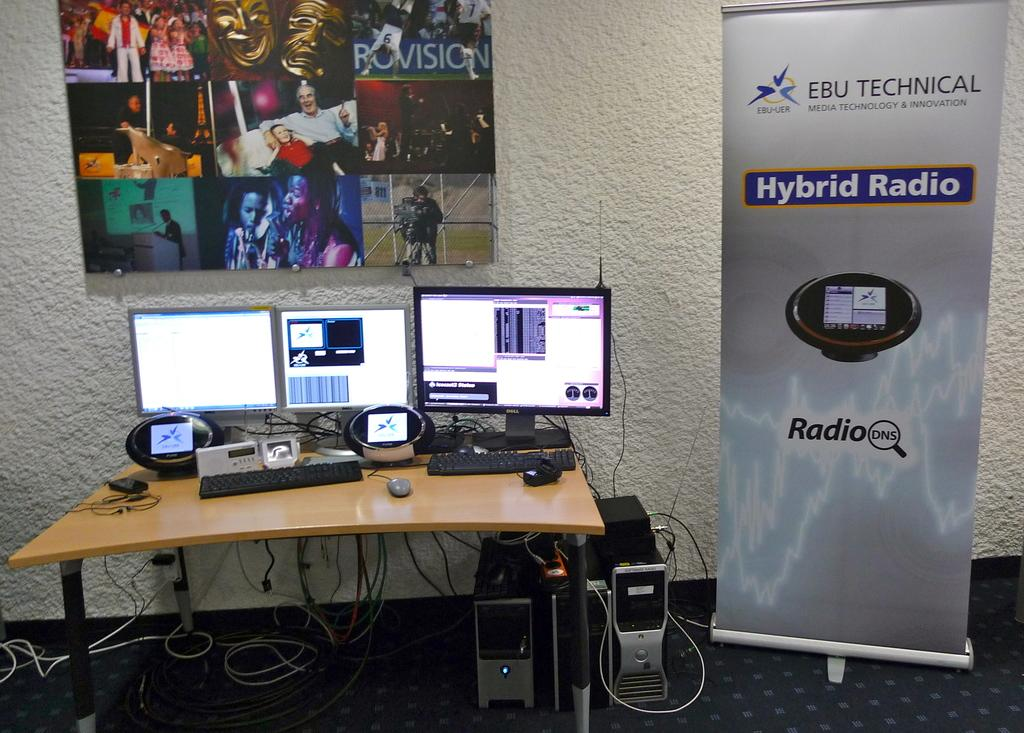<image>
Create a compact narrative representing the image presented. A computer desk placed next to a banner for EBU TECHNICAL Hyprid Radio. 